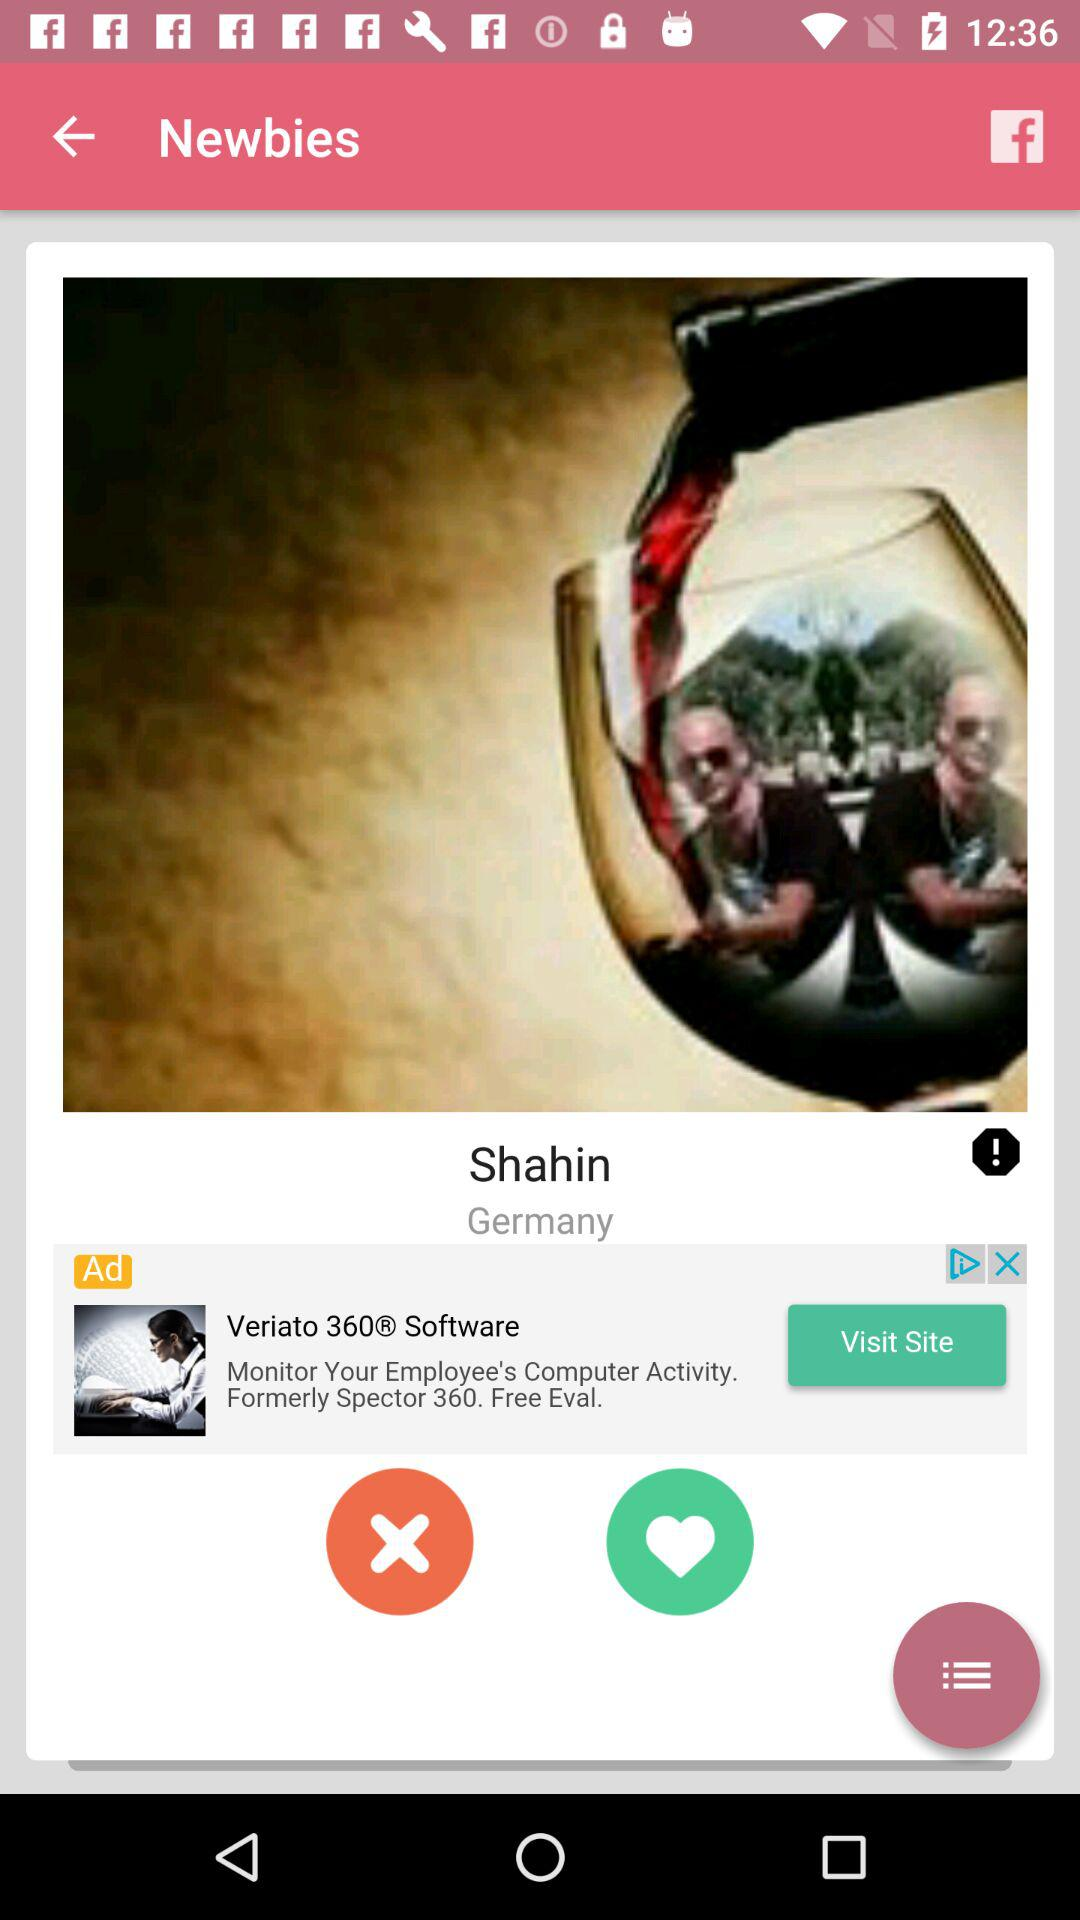What is the mentioned location? The mentioned location is Germany. 